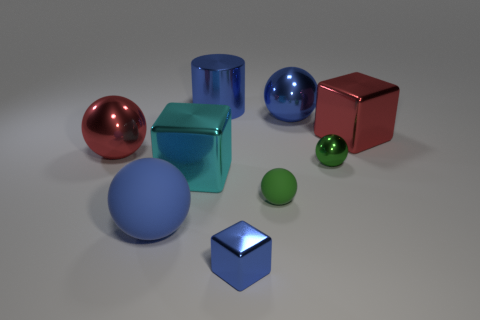Subtract all green cylinders. How many green balls are left? 2 Subtract all big red spheres. How many spheres are left? 4 Subtract all red balls. How many balls are left? 4 Add 1 big purple cylinders. How many objects exist? 10 Subtract all cylinders. How many objects are left? 8 Subtract all green cubes. Subtract all blue balls. How many cubes are left? 3 Subtract 0 cyan spheres. How many objects are left? 9 Subtract all large red objects. Subtract all big red shiny cubes. How many objects are left? 6 Add 7 blue metal things. How many blue metal things are left? 10 Add 3 large brown matte cubes. How many large brown matte cubes exist? 3 